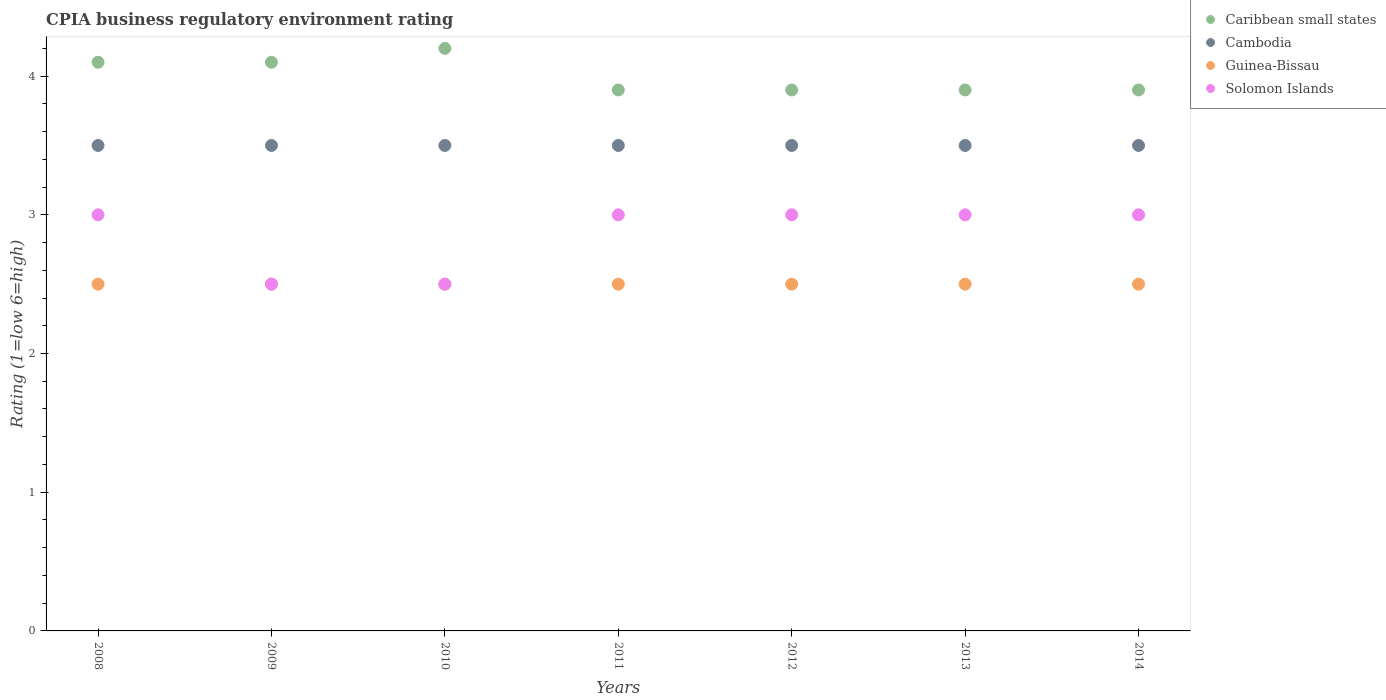Is the number of dotlines equal to the number of legend labels?
Your response must be concise. Yes. What is the CPIA rating in Cambodia in 2012?
Your answer should be compact. 3.5. Across all years, what is the minimum CPIA rating in Caribbean small states?
Offer a terse response. 3.9. What is the total CPIA rating in Guinea-Bissau in the graph?
Provide a short and direct response. 17.5. What is the difference between the CPIA rating in Solomon Islands in 2009 and that in 2013?
Offer a very short reply. -0.5. What is the average CPIA rating in Cambodia per year?
Give a very brief answer. 3.5. In how many years, is the CPIA rating in Cambodia greater than 2?
Ensure brevity in your answer.  7. What is the ratio of the CPIA rating in Guinea-Bissau in 2008 to that in 2014?
Provide a succinct answer. 1. Is the CPIA rating in Caribbean small states in 2008 less than that in 2009?
Provide a short and direct response. No. What is the difference between the highest and the second highest CPIA rating in Caribbean small states?
Ensure brevity in your answer.  0.1. What is the difference between the highest and the lowest CPIA rating in Solomon Islands?
Provide a succinct answer. 0.5. Is the sum of the CPIA rating in Solomon Islands in 2010 and 2013 greater than the maximum CPIA rating in Caribbean small states across all years?
Your answer should be very brief. Yes. Is it the case that in every year, the sum of the CPIA rating in Guinea-Bissau and CPIA rating in Caribbean small states  is greater than the CPIA rating in Solomon Islands?
Provide a succinct answer. Yes. Does the CPIA rating in Solomon Islands monotonically increase over the years?
Ensure brevity in your answer.  No. Is the CPIA rating in Caribbean small states strictly less than the CPIA rating in Cambodia over the years?
Your answer should be compact. No. How many dotlines are there?
Offer a very short reply. 4. What is the difference between two consecutive major ticks on the Y-axis?
Offer a very short reply. 1. Are the values on the major ticks of Y-axis written in scientific E-notation?
Your answer should be very brief. No. How many legend labels are there?
Give a very brief answer. 4. How are the legend labels stacked?
Your response must be concise. Vertical. What is the title of the graph?
Make the answer very short. CPIA business regulatory environment rating. What is the Rating (1=low 6=high) in Caribbean small states in 2008?
Make the answer very short. 4.1. What is the Rating (1=low 6=high) in Cambodia in 2008?
Make the answer very short. 3.5. What is the Rating (1=low 6=high) in Guinea-Bissau in 2008?
Your answer should be compact. 2.5. What is the Rating (1=low 6=high) of Caribbean small states in 2009?
Offer a terse response. 4.1. What is the Rating (1=low 6=high) in Guinea-Bissau in 2009?
Provide a succinct answer. 2.5. What is the Rating (1=low 6=high) in Cambodia in 2010?
Ensure brevity in your answer.  3.5. What is the Rating (1=low 6=high) of Cambodia in 2011?
Ensure brevity in your answer.  3.5. What is the Rating (1=low 6=high) of Guinea-Bissau in 2011?
Make the answer very short. 2.5. What is the Rating (1=low 6=high) in Solomon Islands in 2011?
Your answer should be very brief. 3. What is the Rating (1=low 6=high) in Guinea-Bissau in 2012?
Offer a very short reply. 2.5. What is the Rating (1=low 6=high) of Caribbean small states in 2013?
Your response must be concise. 3.9. What is the Rating (1=low 6=high) in Guinea-Bissau in 2013?
Keep it short and to the point. 2.5. What is the Rating (1=low 6=high) of Caribbean small states in 2014?
Give a very brief answer. 3.9. What is the Rating (1=low 6=high) of Cambodia in 2014?
Make the answer very short. 3.5. What is the Rating (1=low 6=high) in Solomon Islands in 2014?
Provide a succinct answer. 3. Across all years, what is the maximum Rating (1=low 6=high) of Guinea-Bissau?
Offer a very short reply. 2.5. Across all years, what is the minimum Rating (1=low 6=high) in Guinea-Bissau?
Offer a very short reply. 2.5. What is the total Rating (1=low 6=high) in Solomon Islands in the graph?
Give a very brief answer. 20. What is the difference between the Rating (1=low 6=high) of Caribbean small states in 2008 and that in 2009?
Offer a very short reply. 0. What is the difference between the Rating (1=low 6=high) of Cambodia in 2008 and that in 2009?
Give a very brief answer. 0. What is the difference between the Rating (1=low 6=high) in Guinea-Bissau in 2008 and that in 2009?
Make the answer very short. 0. What is the difference between the Rating (1=low 6=high) in Guinea-Bissau in 2008 and that in 2010?
Provide a succinct answer. 0. What is the difference between the Rating (1=low 6=high) in Solomon Islands in 2008 and that in 2010?
Your response must be concise. 0.5. What is the difference between the Rating (1=low 6=high) of Guinea-Bissau in 2008 and that in 2012?
Make the answer very short. 0. What is the difference between the Rating (1=low 6=high) of Caribbean small states in 2008 and that in 2013?
Offer a terse response. 0.2. What is the difference between the Rating (1=low 6=high) of Solomon Islands in 2008 and that in 2013?
Give a very brief answer. 0. What is the difference between the Rating (1=low 6=high) in Cambodia in 2008 and that in 2014?
Make the answer very short. 0. What is the difference between the Rating (1=low 6=high) of Cambodia in 2009 and that in 2010?
Ensure brevity in your answer.  0. What is the difference between the Rating (1=low 6=high) of Solomon Islands in 2009 and that in 2010?
Your response must be concise. 0. What is the difference between the Rating (1=low 6=high) in Cambodia in 2009 and that in 2011?
Your answer should be compact. 0. What is the difference between the Rating (1=low 6=high) in Solomon Islands in 2009 and that in 2012?
Make the answer very short. -0.5. What is the difference between the Rating (1=low 6=high) in Cambodia in 2009 and that in 2013?
Your response must be concise. 0. What is the difference between the Rating (1=low 6=high) of Guinea-Bissau in 2009 and that in 2013?
Your response must be concise. 0. What is the difference between the Rating (1=low 6=high) of Solomon Islands in 2009 and that in 2013?
Offer a terse response. -0.5. What is the difference between the Rating (1=low 6=high) in Guinea-Bissau in 2009 and that in 2014?
Provide a short and direct response. 0. What is the difference between the Rating (1=low 6=high) of Solomon Islands in 2009 and that in 2014?
Provide a short and direct response. -0.5. What is the difference between the Rating (1=low 6=high) in Caribbean small states in 2010 and that in 2011?
Your answer should be very brief. 0.3. What is the difference between the Rating (1=low 6=high) in Cambodia in 2010 and that in 2011?
Offer a very short reply. 0. What is the difference between the Rating (1=low 6=high) of Guinea-Bissau in 2010 and that in 2011?
Provide a short and direct response. 0. What is the difference between the Rating (1=low 6=high) in Guinea-Bissau in 2010 and that in 2012?
Offer a terse response. 0. What is the difference between the Rating (1=low 6=high) of Solomon Islands in 2010 and that in 2012?
Keep it short and to the point. -0.5. What is the difference between the Rating (1=low 6=high) of Caribbean small states in 2010 and that in 2013?
Give a very brief answer. 0.3. What is the difference between the Rating (1=low 6=high) in Cambodia in 2010 and that in 2013?
Provide a succinct answer. 0. What is the difference between the Rating (1=low 6=high) of Guinea-Bissau in 2010 and that in 2013?
Provide a succinct answer. 0. What is the difference between the Rating (1=low 6=high) in Solomon Islands in 2010 and that in 2013?
Keep it short and to the point. -0.5. What is the difference between the Rating (1=low 6=high) in Caribbean small states in 2010 and that in 2014?
Offer a very short reply. 0.3. What is the difference between the Rating (1=low 6=high) in Cambodia in 2010 and that in 2014?
Your answer should be very brief. 0. What is the difference between the Rating (1=low 6=high) of Guinea-Bissau in 2010 and that in 2014?
Offer a very short reply. 0. What is the difference between the Rating (1=low 6=high) in Solomon Islands in 2010 and that in 2014?
Make the answer very short. -0.5. What is the difference between the Rating (1=low 6=high) in Cambodia in 2011 and that in 2012?
Give a very brief answer. 0. What is the difference between the Rating (1=low 6=high) of Solomon Islands in 2011 and that in 2012?
Offer a terse response. 0. What is the difference between the Rating (1=low 6=high) in Caribbean small states in 2011 and that in 2013?
Give a very brief answer. 0. What is the difference between the Rating (1=low 6=high) in Solomon Islands in 2011 and that in 2013?
Provide a short and direct response. 0. What is the difference between the Rating (1=low 6=high) of Solomon Islands in 2011 and that in 2014?
Provide a succinct answer. 0. What is the difference between the Rating (1=low 6=high) in Caribbean small states in 2012 and that in 2013?
Give a very brief answer. 0. What is the difference between the Rating (1=low 6=high) in Cambodia in 2012 and that in 2013?
Ensure brevity in your answer.  0. What is the difference between the Rating (1=low 6=high) of Caribbean small states in 2012 and that in 2014?
Provide a short and direct response. 0. What is the difference between the Rating (1=low 6=high) in Guinea-Bissau in 2012 and that in 2014?
Keep it short and to the point. 0. What is the difference between the Rating (1=low 6=high) of Caribbean small states in 2008 and the Rating (1=low 6=high) of Cambodia in 2009?
Offer a very short reply. 0.6. What is the difference between the Rating (1=low 6=high) in Caribbean small states in 2008 and the Rating (1=low 6=high) in Solomon Islands in 2009?
Provide a short and direct response. 1.6. What is the difference between the Rating (1=low 6=high) in Guinea-Bissau in 2008 and the Rating (1=low 6=high) in Solomon Islands in 2009?
Your answer should be compact. 0. What is the difference between the Rating (1=low 6=high) in Caribbean small states in 2008 and the Rating (1=low 6=high) in Solomon Islands in 2010?
Your response must be concise. 1.6. What is the difference between the Rating (1=low 6=high) of Cambodia in 2008 and the Rating (1=low 6=high) of Guinea-Bissau in 2010?
Offer a terse response. 1. What is the difference between the Rating (1=low 6=high) in Cambodia in 2008 and the Rating (1=low 6=high) in Solomon Islands in 2010?
Provide a short and direct response. 1. What is the difference between the Rating (1=low 6=high) of Guinea-Bissau in 2008 and the Rating (1=low 6=high) of Solomon Islands in 2010?
Give a very brief answer. 0. What is the difference between the Rating (1=low 6=high) of Caribbean small states in 2008 and the Rating (1=low 6=high) of Guinea-Bissau in 2011?
Make the answer very short. 1.6. What is the difference between the Rating (1=low 6=high) of Guinea-Bissau in 2008 and the Rating (1=low 6=high) of Solomon Islands in 2011?
Your response must be concise. -0.5. What is the difference between the Rating (1=low 6=high) in Caribbean small states in 2008 and the Rating (1=low 6=high) in Solomon Islands in 2012?
Your response must be concise. 1.1. What is the difference between the Rating (1=low 6=high) of Cambodia in 2008 and the Rating (1=low 6=high) of Solomon Islands in 2012?
Give a very brief answer. 0.5. What is the difference between the Rating (1=low 6=high) of Caribbean small states in 2008 and the Rating (1=low 6=high) of Guinea-Bissau in 2013?
Provide a short and direct response. 1.6. What is the difference between the Rating (1=low 6=high) of Caribbean small states in 2008 and the Rating (1=low 6=high) of Cambodia in 2014?
Make the answer very short. 0.6. What is the difference between the Rating (1=low 6=high) in Cambodia in 2008 and the Rating (1=low 6=high) in Guinea-Bissau in 2014?
Ensure brevity in your answer.  1. What is the difference between the Rating (1=low 6=high) of Cambodia in 2008 and the Rating (1=low 6=high) of Solomon Islands in 2014?
Provide a succinct answer. 0.5. What is the difference between the Rating (1=low 6=high) in Guinea-Bissau in 2008 and the Rating (1=low 6=high) in Solomon Islands in 2014?
Make the answer very short. -0.5. What is the difference between the Rating (1=low 6=high) in Caribbean small states in 2009 and the Rating (1=low 6=high) in Guinea-Bissau in 2010?
Offer a terse response. 1.6. What is the difference between the Rating (1=low 6=high) of Caribbean small states in 2009 and the Rating (1=low 6=high) of Solomon Islands in 2010?
Your response must be concise. 1.6. What is the difference between the Rating (1=low 6=high) of Cambodia in 2009 and the Rating (1=low 6=high) of Guinea-Bissau in 2010?
Your answer should be compact. 1. What is the difference between the Rating (1=low 6=high) in Guinea-Bissau in 2009 and the Rating (1=low 6=high) in Solomon Islands in 2010?
Your response must be concise. 0. What is the difference between the Rating (1=low 6=high) in Caribbean small states in 2009 and the Rating (1=low 6=high) in Cambodia in 2011?
Offer a terse response. 0.6. What is the difference between the Rating (1=low 6=high) of Caribbean small states in 2009 and the Rating (1=low 6=high) of Guinea-Bissau in 2011?
Ensure brevity in your answer.  1.6. What is the difference between the Rating (1=low 6=high) in Caribbean small states in 2009 and the Rating (1=low 6=high) in Solomon Islands in 2011?
Ensure brevity in your answer.  1.1. What is the difference between the Rating (1=low 6=high) in Guinea-Bissau in 2009 and the Rating (1=low 6=high) in Solomon Islands in 2011?
Make the answer very short. -0.5. What is the difference between the Rating (1=low 6=high) in Caribbean small states in 2009 and the Rating (1=low 6=high) in Cambodia in 2012?
Make the answer very short. 0.6. What is the difference between the Rating (1=low 6=high) in Caribbean small states in 2009 and the Rating (1=low 6=high) in Solomon Islands in 2012?
Make the answer very short. 1.1. What is the difference between the Rating (1=low 6=high) of Cambodia in 2009 and the Rating (1=low 6=high) of Solomon Islands in 2012?
Your answer should be very brief. 0.5. What is the difference between the Rating (1=low 6=high) of Caribbean small states in 2009 and the Rating (1=low 6=high) of Solomon Islands in 2013?
Make the answer very short. 1.1. What is the difference between the Rating (1=low 6=high) in Cambodia in 2009 and the Rating (1=low 6=high) in Solomon Islands in 2013?
Provide a succinct answer. 0.5. What is the difference between the Rating (1=low 6=high) of Guinea-Bissau in 2009 and the Rating (1=low 6=high) of Solomon Islands in 2013?
Make the answer very short. -0.5. What is the difference between the Rating (1=low 6=high) in Caribbean small states in 2009 and the Rating (1=low 6=high) in Guinea-Bissau in 2014?
Your answer should be very brief. 1.6. What is the difference between the Rating (1=low 6=high) in Cambodia in 2009 and the Rating (1=low 6=high) in Guinea-Bissau in 2014?
Your response must be concise. 1. What is the difference between the Rating (1=low 6=high) in Cambodia in 2009 and the Rating (1=low 6=high) in Solomon Islands in 2014?
Your answer should be compact. 0.5. What is the difference between the Rating (1=low 6=high) of Caribbean small states in 2010 and the Rating (1=low 6=high) of Guinea-Bissau in 2011?
Offer a very short reply. 1.7. What is the difference between the Rating (1=low 6=high) in Caribbean small states in 2010 and the Rating (1=low 6=high) in Solomon Islands in 2011?
Your response must be concise. 1.2. What is the difference between the Rating (1=low 6=high) of Cambodia in 2010 and the Rating (1=low 6=high) of Guinea-Bissau in 2011?
Provide a succinct answer. 1. What is the difference between the Rating (1=low 6=high) of Caribbean small states in 2010 and the Rating (1=low 6=high) of Cambodia in 2012?
Ensure brevity in your answer.  0.7. What is the difference between the Rating (1=low 6=high) of Caribbean small states in 2010 and the Rating (1=low 6=high) of Solomon Islands in 2012?
Your answer should be compact. 1.2. What is the difference between the Rating (1=low 6=high) in Caribbean small states in 2010 and the Rating (1=low 6=high) in Cambodia in 2013?
Ensure brevity in your answer.  0.7. What is the difference between the Rating (1=low 6=high) in Caribbean small states in 2010 and the Rating (1=low 6=high) in Solomon Islands in 2013?
Provide a short and direct response. 1.2. What is the difference between the Rating (1=low 6=high) of Cambodia in 2010 and the Rating (1=low 6=high) of Guinea-Bissau in 2013?
Keep it short and to the point. 1. What is the difference between the Rating (1=low 6=high) in Guinea-Bissau in 2010 and the Rating (1=low 6=high) in Solomon Islands in 2013?
Ensure brevity in your answer.  -0.5. What is the difference between the Rating (1=low 6=high) of Caribbean small states in 2010 and the Rating (1=low 6=high) of Cambodia in 2014?
Offer a very short reply. 0.7. What is the difference between the Rating (1=low 6=high) of Cambodia in 2010 and the Rating (1=low 6=high) of Guinea-Bissau in 2014?
Offer a terse response. 1. What is the difference between the Rating (1=low 6=high) of Guinea-Bissau in 2010 and the Rating (1=low 6=high) of Solomon Islands in 2014?
Ensure brevity in your answer.  -0.5. What is the difference between the Rating (1=low 6=high) in Caribbean small states in 2011 and the Rating (1=low 6=high) in Cambodia in 2012?
Your response must be concise. 0.4. What is the difference between the Rating (1=low 6=high) of Caribbean small states in 2011 and the Rating (1=low 6=high) of Guinea-Bissau in 2012?
Your answer should be very brief. 1.4. What is the difference between the Rating (1=low 6=high) of Caribbean small states in 2011 and the Rating (1=low 6=high) of Solomon Islands in 2012?
Offer a terse response. 0.9. What is the difference between the Rating (1=low 6=high) in Cambodia in 2011 and the Rating (1=low 6=high) in Guinea-Bissau in 2012?
Provide a short and direct response. 1. What is the difference between the Rating (1=low 6=high) in Cambodia in 2011 and the Rating (1=low 6=high) in Solomon Islands in 2012?
Your answer should be compact. 0.5. What is the difference between the Rating (1=low 6=high) in Guinea-Bissau in 2011 and the Rating (1=low 6=high) in Solomon Islands in 2012?
Keep it short and to the point. -0.5. What is the difference between the Rating (1=low 6=high) of Caribbean small states in 2011 and the Rating (1=low 6=high) of Guinea-Bissau in 2013?
Your answer should be compact. 1.4. What is the difference between the Rating (1=low 6=high) of Caribbean small states in 2011 and the Rating (1=low 6=high) of Solomon Islands in 2013?
Make the answer very short. 0.9. What is the difference between the Rating (1=low 6=high) in Cambodia in 2011 and the Rating (1=low 6=high) in Solomon Islands in 2013?
Ensure brevity in your answer.  0.5. What is the difference between the Rating (1=low 6=high) in Caribbean small states in 2011 and the Rating (1=low 6=high) in Solomon Islands in 2014?
Give a very brief answer. 0.9. What is the difference between the Rating (1=low 6=high) of Cambodia in 2011 and the Rating (1=low 6=high) of Guinea-Bissau in 2014?
Provide a succinct answer. 1. What is the difference between the Rating (1=low 6=high) of Caribbean small states in 2012 and the Rating (1=low 6=high) of Solomon Islands in 2013?
Your answer should be very brief. 0.9. What is the difference between the Rating (1=low 6=high) of Cambodia in 2012 and the Rating (1=low 6=high) of Guinea-Bissau in 2013?
Your response must be concise. 1. What is the difference between the Rating (1=low 6=high) in Cambodia in 2012 and the Rating (1=low 6=high) in Solomon Islands in 2013?
Offer a very short reply. 0.5. What is the difference between the Rating (1=low 6=high) in Guinea-Bissau in 2012 and the Rating (1=low 6=high) in Solomon Islands in 2013?
Offer a very short reply. -0.5. What is the difference between the Rating (1=low 6=high) in Caribbean small states in 2012 and the Rating (1=low 6=high) in Solomon Islands in 2014?
Your answer should be very brief. 0.9. What is the difference between the Rating (1=low 6=high) in Cambodia in 2012 and the Rating (1=low 6=high) in Guinea-Bissau in 2014?
Your answer should be compact. 1. What is the difference between the Rating (1=low 6=high) of Cambodia in 2013 and the Rating (1=low 6=high) of Guinea-Bissau in 2014?
Make the answer very short. 1. What is the difference between the Rating (1=low 6=high) of Cambodia in 2013 and the Rating (1=low 6=high) of Solomon Islands in 2014?
Provide a short and direct response. 0.5. What is the difference between the Rating (1=low 6=high) of Guinea-Bissau in 2013 and the Rating (1=low 6=high) of Solomon Islands in 2014?
Provide a succinct answer. -0.5. What is the average Rating (1=low 6=high) of Cambodia per year?
Give a very brief answer. 3.5. What is the average Rating (1=low 6=high) in Guinea-Bissau per year?
Ensure brevity in your answer.  2.5. What is the average Rating (1=low 6=high) of Solomon Islands per year?
Make the answer very short. 2.86. In the year 2008, what is the difference between the Rating (1=low 6=high) of Caribbean small states and Rating (1=low 6=high) of Guinea-Bissau?
Make the answer very short. 1.6. In the year 2008, what is the difference between the Rating (1=low 6=high) in Caribbean small states and Rating (1=low 6=high) in Solomon Islands?
Offer a terse response. 1.1. In the year 2008, what is the difference between the Rating (1=low 6=high) in Cambodia and Rating (1=low 6=high) in Solomon Islands?
Offer a terse response. 0.5. In the year 2009, what is the difference between the Rating (1=low 6=high) in Caribbean small states and Rating (1=low 6=high) in Cambodia?
Offer a very short reply. 0.6. In the year 2009, what is the difference between the Rating (1=low 6=high) of Caribbean small states and Rating (1=low 6=high) of Guinea-Bissau?
Offer a terse response. 1.6. In the year 2010, what is the difference between the Rating (1=low 6=high) of Caribbean small states and Rating (1=low 6=high) of Solomon Islands?
Your response must be concise. 1.7. In the year 2010, what is the difference between the Rating (1=low 6=high) of Cambodia and Rating (1=low 6=high) of Guinea-Bissau?
Offer a very short reply. 1. In the year 2010, what is the difference between the Rating (1=low 6=high) in Cambodia and Rating (1=low 6=high) in Solomon Islands?
Ensure brevity in your answer.  1. In the year 2011, what is the difference between the Rating (1=low 6=high) in Caribbean small states and Rating (1=low 6=high) in Cambodia?
Offer a terse response. 0.4. In the year 2011, what is the difference between the Rating (1=low 6=high) of Cambodia and Rating (1=low 6=high) of Solomon Islands?
Offer a very short reply. 0.5. In the year 2012, what is the difference between the Rating (1=low 6=high) of Caribbean small states and Rating (1=low 6=high) of Cambodia?
Make the answer very short. 0.4. In the year 2012, what is the difference between the Rating (1=low 6=high) of Cambodia and Rating (1=low 6=high) of Guinea-Bissau?
Offer a very short reply. 1. In the year 2012, what is the difference between the Rating (1=low 6=high) in Cambodia and Rating (1=low 6=high) in Solomon Islands?
Provide a succinct answer. 0.5. In the year 2012, what is the difference between the Rating (1=low 6=high) in Guinea-Bissau and Rating (1=low 6=high) in Solomon Islands?
Your response must be concise. -0.5. In the year 2013, what is the difference between the Rating (1=low 6=high) in Caribbean small states and Rating (1=low 6=high) in Cambodia?
Ensure brevity in your answer.  0.4. In the year 2013, what is the difference between the Rating (1=low 6=high) in Caribbean small states and Rating (1=low 6=high) in Solomon Islands?
Give a very brief answer. 0.9. In the year 2013, what is the difference between the Rating (1=low 6=high) of Guinea-Bissau and Rating (1=low 6=high) of Solomon Islands?
Make the answer very short. -0.5. In the year 2014, what is the difference between the Rating (1=low 6=high) of Caribbean small states and Rating (1=low 6=high) of Cambodia?
Your answer should be compact. 0.4. In the year 2014, what is the difference between the Rating (1=low 6=high) in Cambodia and Rating (1=low 6=high) in Solomon Islands?
Offer a terse response. 0.5. What is the ratio of the Rating (1=low 6=high) of Caribbean small states in 2008 to that in 2010?
Your answer should be very brief. 0.98. What is the ratio of the Rating (1=low 6=high) of Cambodia in 2008 to that in 2010?
Give a very brief answer. 1. What is the ratio of the Rating (1=low 6=high) of Guinea-Bissau in 2008 to that in 2010?
Make the answer very short. 1. What is the ratio of the Rating (1=low 6=high) of Solomon Islands in 2008 to that in 2010?
Give a very brief answer. 1.2. What is the ratio of the Rating (1=low 6=high) in Caribbean small states in 2008 to that in 2011?
Ensure brevity in your answer.  1.05. What is the ratio of the Rating (1=low 6=high) in Cambodia in 2008 to that in 2011?
Make the answer very short. 1. What is the ratio of the Rating (1=low 6=high) in Solomon Islands in 2008 to that in 2011?
Provide a short and direct response. 1. What is the ratio of the Rating (1=low 6=high) in Caribbean small states in 2008 to that in 2012?
Ensure brevity in your answer.  1.05. What is the ratio of the Rating (1=low 6=high) in Guinea-Bissau in 2008 to that in 2012?
Offer a terse response. 1. What is the ratio of the Rating (1=low 6=high) in Solomon Islands in 2008 to that in 2012?
Make the answer very short. 1. What is the ratio of the Rating (1=low 6=high) of Caribbean small states in 2008 to that in 2013?
Your response must be concise. 1.05. What is the ratio of the Rating (1=low 6=high) of Guinea-Bissau in 2008 to that in 2013?
Give a very brief answer. 1. What is the ratio of the Rating (1=low 6=high) in Caribbean small states in 2008 to that in 2014?
Offer a very short reply. 1.05. What is the ratio of the Rating (1=low 6=high) in Guinea-Bissau in 2008 to that in 2014?
Provide a short and direct response. 1. What is the ratio of the Rating (1=low 6=high) in Solomon Islands in 2008 to that in 2014?
Your answer should be very brief. 1. What is the ratio of the Rating (1=low 6=high) in Caribbean small states in 2009 to that in 2010?
Provide a succinct answer. 0.98. What is the ratio of the Rating (1=low 6=high) of Guinea-Bissau in 2009 to that in 2010?
Your answer should be compact. 1. What is the ratio of the Rating (1=low 6=high) in Caribbean small states in 2009 to that in 2011?
Your answer should be very brief. 1.05. What is the ratio of the Rating (1=low 6=high) of Caribbean small states in 2009 to that in 2012?
Your response must be concise. 1.05. What is the ratio of the Rating (1=low 6=high) in Cambodia in 2009 to that in 2012?
Provide a short and direct response. 1. What is the ratio of the Rating (1=low 6=high) in Guinea-Bissau in 2009 to that in 2012?
Your answer should be very brief. 1. What is the ratio of the Rating (1=low 6=high) in Caribbean small states in 2009 to that in 2013?
Provide a succinct answer. 1.05. What is the ratio of the Rating (1=low 6=high) in Guinea-Bissau in 2009 to that in 2013?
Provide a succinct answer. 1. What is the ratio of the Rating (1=low 6=high) in Solomon Islands in 2009 to that in 2013?
Keep it short and to the point. 0.83. What is the ratio of the Rating (1=low 6=high) in Caribbean small states in 2009 to that in 2014?
Give a very brief answer. 1.05. What is the ratio of the Rating (1=low 6=high) of Cambodia in 2009 to that in 2014?
Your response must be concise. 1. What is the ratio of the Rating (1=low 6=high) of Caribbean small states in 2010 to that in 2011?
Keep it short and to the point. 1.08. What is the ratio of the Rating (1=low 6=high) of Cambodia in 2010 to that in 2011?
Offer a very short reply. 1. What is the ratio of the Rating (1=low 6=high) in Caribbean small states in 2010 to that in 2013?
Ensure brevity in your answer.  1.08. What is the ratio of the Rating (1=low 6=high) of Cambodia in 2010 to that in 2013?
Your answer should be compact. 1. What is the ratio of the Rating (1=low 6=high) of Guinea-Bissau in 2010 to that in 2013?
Offer a terse response. 1. What is the ratio of the Rating (1=low 6=high) in Caribbean small states in 2010 to that in 2014?
Your response must be concise. 1.08. What is the ratio of the Rating (1=low 6=high) of Cambodia in 2010 to that in 2014?
Provide a short and direct response. 1. What is the ratio of the Rating (1=low 6=high) of Guinea-Bissau in 2010 to that in 2014?
Give a very brief answer. 1. What is the ratio of the Rating (1=low 6=high) of Solomon Islands in 2010 to that in 2014?
Your answer should be compact. 0.83. What is the ratio of the Rating (1=low 6=high) of Caribbean small states in 2011 to that in 2012?
Ensure brevity in your answer.  1. What is the ratio of the Rating (1=low 6=high) in Cambodia in 2011 to that in 2012?
Your response must be concise. 1. What is the ratio of the Rating (1=low 6=high) in Caribbean small states in 2011 to that in 2013?
Offer a very short reply. 1. What is the ratio of the Rating (1=low 6=high) of Guinea-Bissau in 2011 to that in 2013?
Provide a short and direct response. 1. What is the ratio of the Rating (1=low 6=high) of Guinea-Bissau in 2011 to that in 2014?
Your response must be concise. 1. What is the ratio of the Rating (1=low 6=high) in Cambodia in 2012 to that in 2014?
Provide a short and direct response. 1. What is the ratio of the Rating (1=low 6=high) of Solomon Islands in 2013 to that in 2014?
Offer a very short reply. 1. What is the difference between the highest and the second highest Rating (1=low 6=high) of Cambodia?
Give a very brief answer. 0. What is the difference between the highest and the second highest Rating (1=low 6=high) of Solomon Islands?
Provide a short and direct response. 0. What is the difference between the highest and the lowest Rating (1=low 6=high) of Cambodia?
Offer a terse response. 0. What is the difference between the highest and the lowest Rating (1=low 6=high) of Solomon Islands?
Provide a short and direct response. 0.5. 